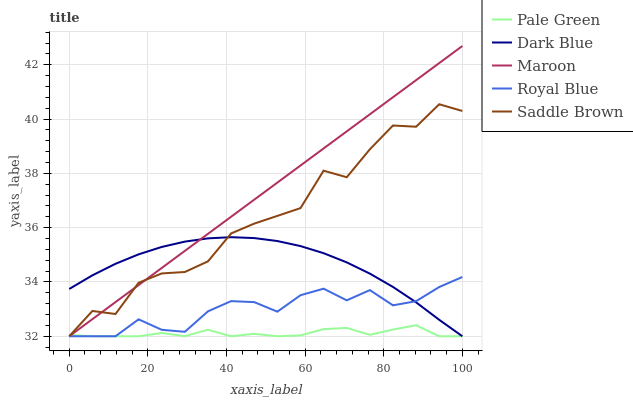Does Pale Green have the minimum area under the curve?
Answer yes or no. Yes. Does Maroon have the maximum area under the curve?
Answer yes or no. Yes. Does Saddle Brown have the minimum area under the curve?
Answer yes or no. No. Does Saddle Brown have the maximum area under the curve?
Answer yes or no. No. Is Maroon the smoothest?
Answer yes or no. Yes. Is Saddle Brown the roughest?
Answer yes or no. Yes. Is Pale Green the smoothest?
Answer yes or no. No. Is Pale Green the roughest?
Answer yes or no. No. Does Maroon have the highest value?
Answer yes or no. Yes. Does Saddle Brown have the highest value?
Answer yes or no. No. 